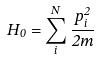Convert formula to latex. <formula><loc_0><loc_0><loc_500><loc_500>H _ { 0 } = \sum _ { i } ^ { N } \frac { p _ { i } ^ { 2 } } { 2 m }</formula> 